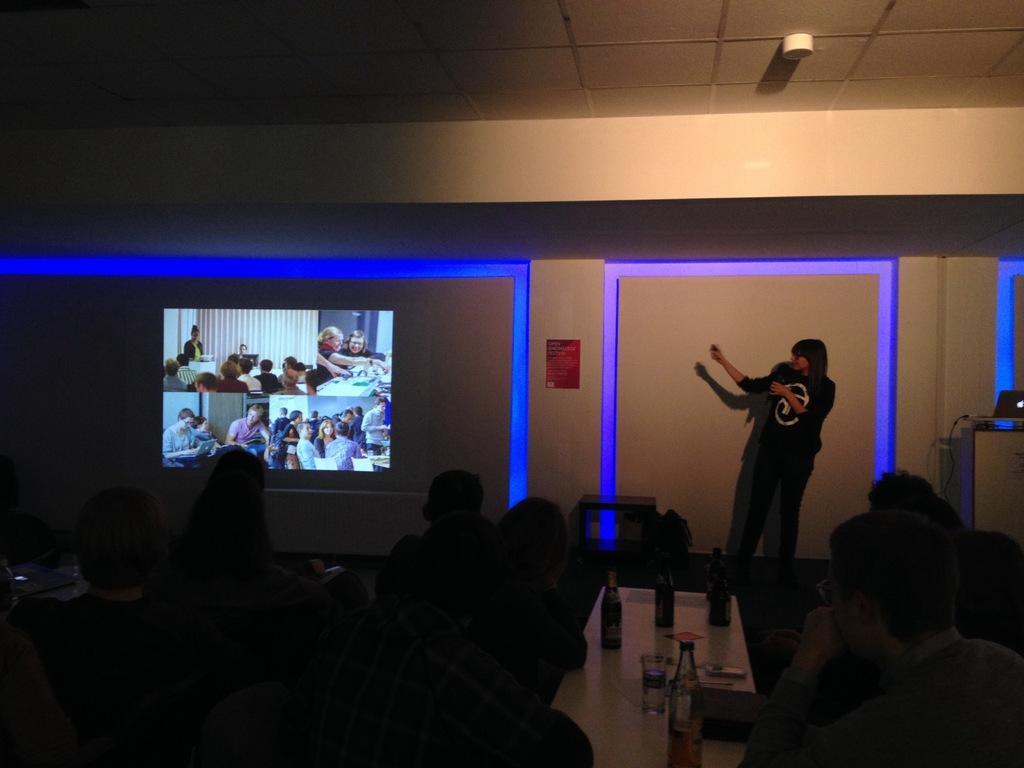Can you describe this image briefly? In this image there are a group of people who are sitting and on the right side there is one woman who is standing and talking and on the top there is ceiling and on the left side there is a screen and some lights are there, and in the bottom there is one table. On that table there are some bottles and one glass is there. 